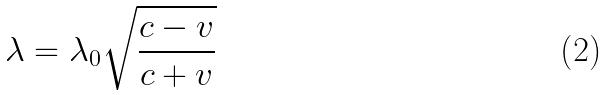Convert formula to latex. <formula><loc_0><loc_0><loc_500><loc_500>\lambda = \lambda _ { 0 } \sqrt { \frac { c - v } { c + v } }</formula> 